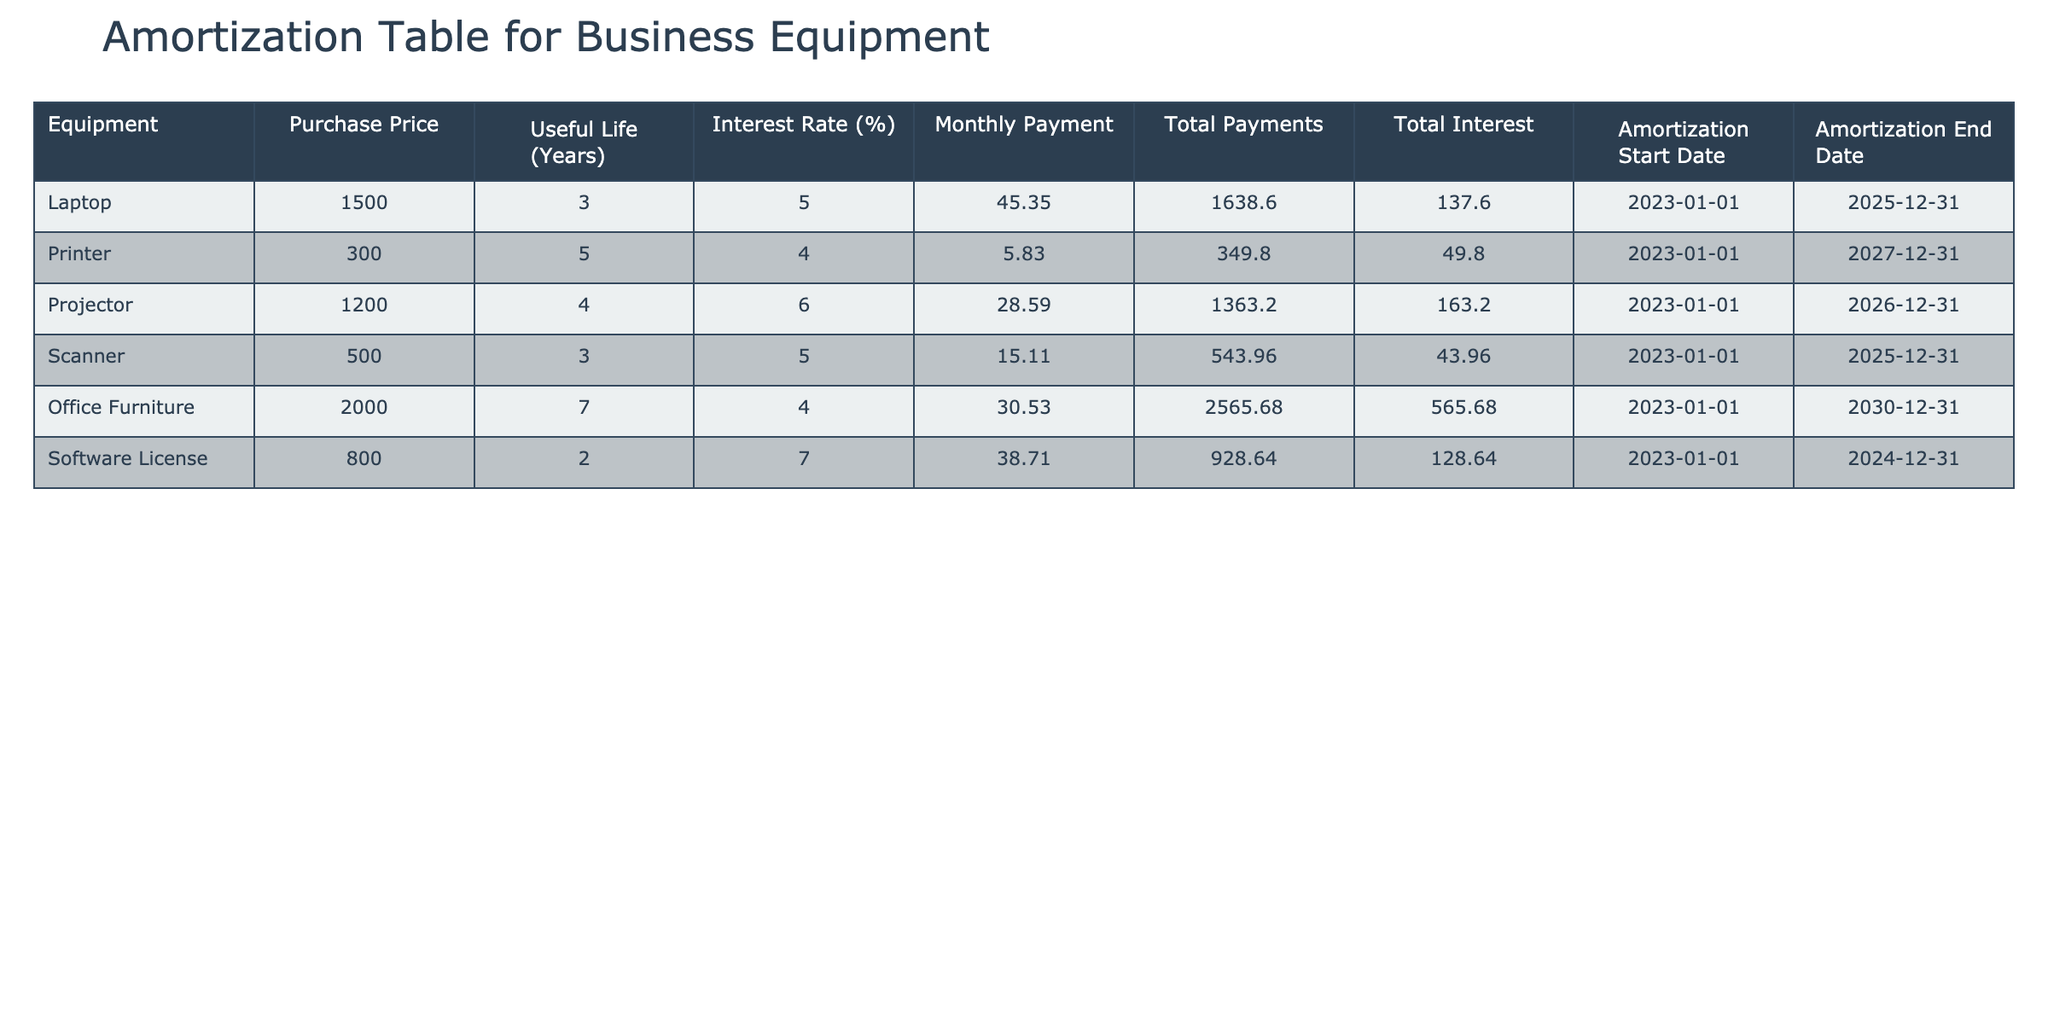What is the purchase price of the Printer? The table indicates that the Printer has a purchase price listed under the 'Purchase Price' column. By checking this column for the row pertaining to the Printer, we find it to be 300.
Answer: 300 What is the total interest paid on the Laptop? The table provides the total interest for each equipment item in the 'Total Interest' column. Looking at the row for the Laptop, the total interest paid is 137.60.
Answer: 137.60 Which equipment has the longest useful life? To find the equipment with the longest useful life, we can compare the values in the 'Useful Life (Years)' column. The Office Furniture has the highest value at 7 years.
Answer: Office Furniture What is the average monthly payment for all the equipment? We will sum all the monthly payments listed in the 'Monthly Payment' column and then divide by the number of equipment items. The sum is (45.35 + 5.83 + 28.59 + 15.11 + 30.53 + 38.71) = 164.12. There are 6 equipment items, so we divide 164.12 by 6, giving approximately 27.35.
Answer: 27.35 Is the total payment for the Software License greater than the total payments for the Scanner? The total payment for the Software License is 928.64, and for the Scanner, it is 543.96. Comparing the two values, 928.64 is greater than 543.96, making the statement true.
Answer: Yes What is the total interest for the Office Furniture and the Projector combined? To find this, we look at the 'Total Interest' column for both the Office Furniture (565.68) and Projector (163.20). Adding these values gives: 565.68 + 163.20 = 728.88.
Answer: 728.88 Does the Printer have a higher monthly payment than the Laptop? By examining the 'Monthly Payment' values, the Printer's payment is 5.83, while the Laptop's is 45.35. Since 5.83 is less than 45.35, the statement is false.
Answer: No What is the total useful life of all equipment items combined? We sum the useful lives from the 'Useful Life (Years)' column: (3 + 5 + 4 + 3 + 7 + 2) = 24 years. This value represents the total useful life across all items.
Answer: 24 If the amortization period for the Scanner were extended by two years, what would its new end date be? The current end date for the Scanner is 2025-12-31. Extending by two years would result in an end date of 2027-12-31, as we simply add two years to the existing year.
Answer: 2027-12-31 